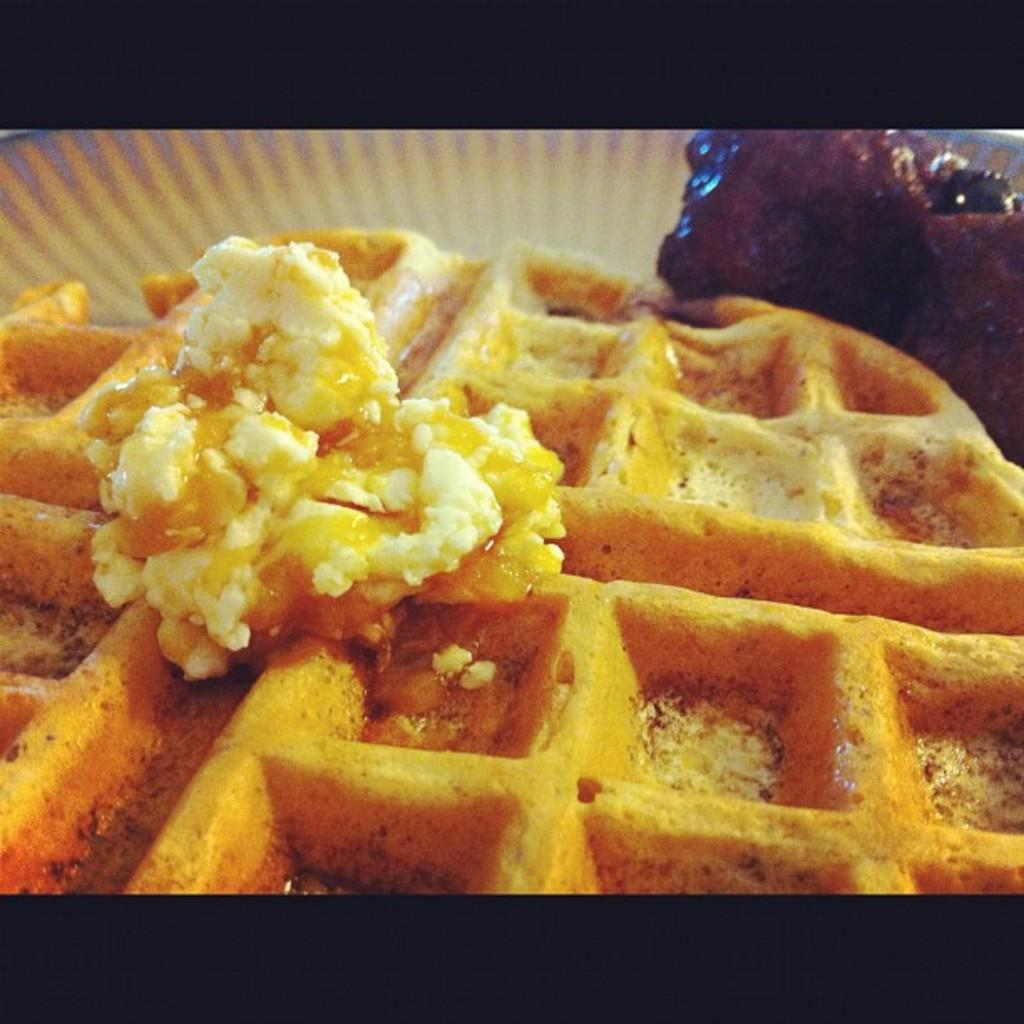What type of items can be seen in the image? There are food products in the image. Where are the food products located? The food products are placed on an object. What type of organization is responsible for the food products in the image? There is no information about an organization in the image, as it only shows food products placed on an object. 